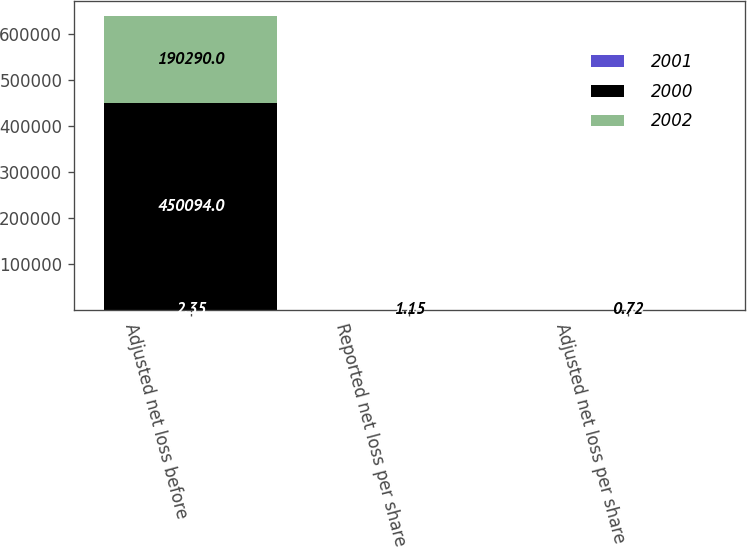<chart> <loc_0><loc_0><loc_500><loc_500><stacked_bar_chart><ecel><fcel>Adjusted net loss before<fcel>Reported net loss per share<fcel>Adjusted net loss per share<nl><fcel>2001<fcel>2.35<fcel>5.84<fcel>5.84<nl><fcel>2000<fcel>450094<fcel>2.35<fcel>1.89<nl><fcel>2002<fcel>190290<fcel>1.15<fcel>0.72<nl></chart> 